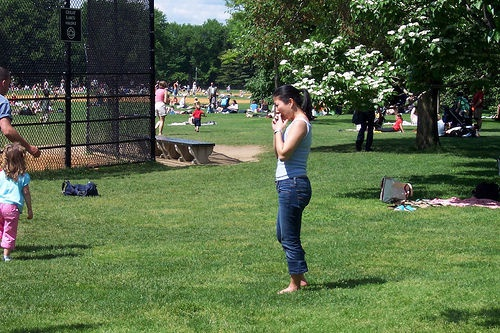Describe the objects in this image and their specific colors. I can see people in darkgreen, black, navy, white, and blue tones, people in darkgreen, white, maroon, gray, and black tones, bench in darkgreen, black, gray, and darkgray tones, people in darkgreen, black, gray, and green tones, and people in darkgreen, black, maroon, brown, and lightpink tones in this image. 